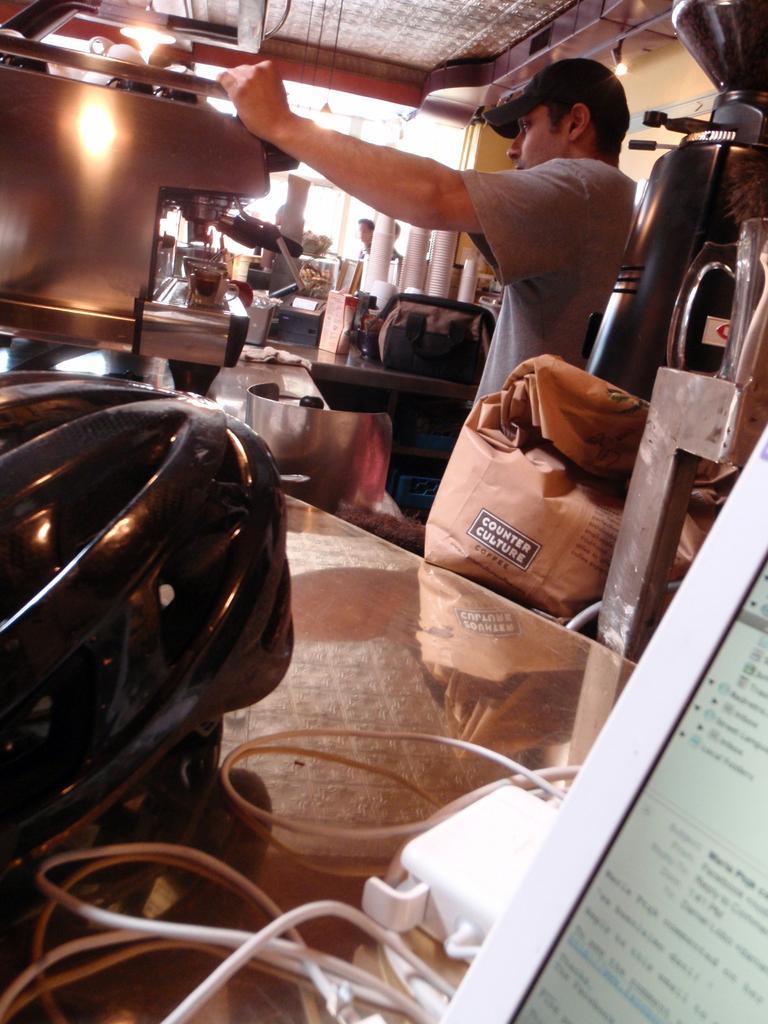In one or two sentences, can you explain what this image depicts? In this picture I can see the man who is standing near to the machine. On the platform I can see the helmet, cables, screens and other objects. In the back I can see the persons who are standing near to the door. At the top there is a roof of the building. In the top right corner I can see the lights. 